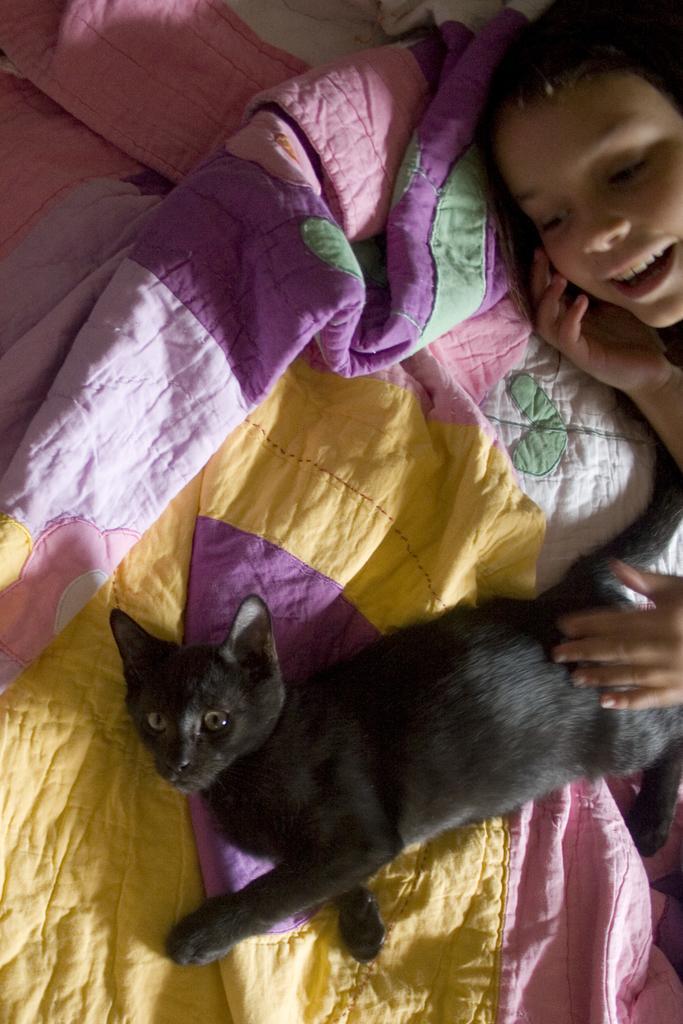How would you summarize this image in a sentence or two? In this picture there is a girl lying on the bed and there is a black cat lying on the bed. 